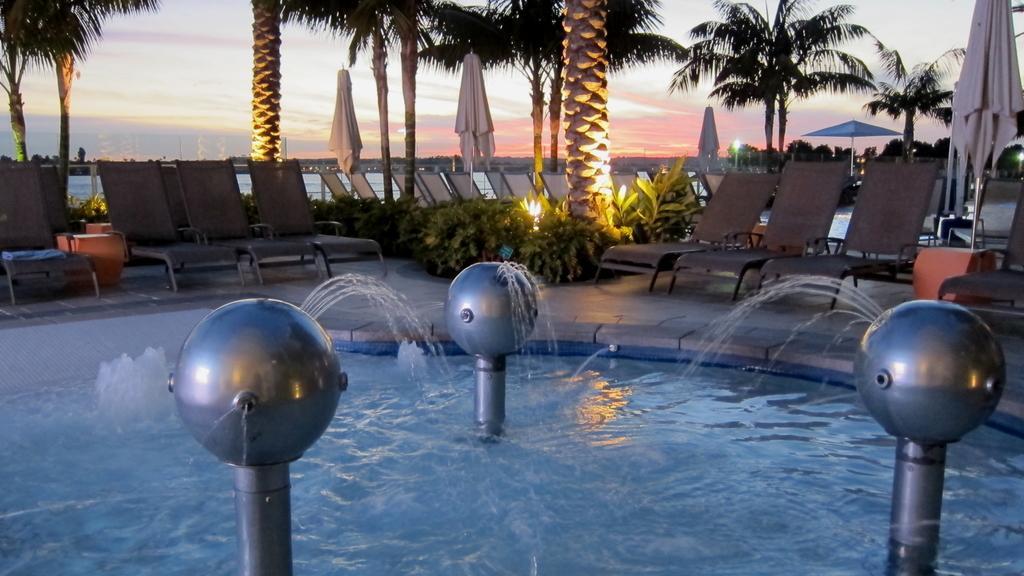Can you describe this image briefly? There are chairs and trees, this is water and a sky. 